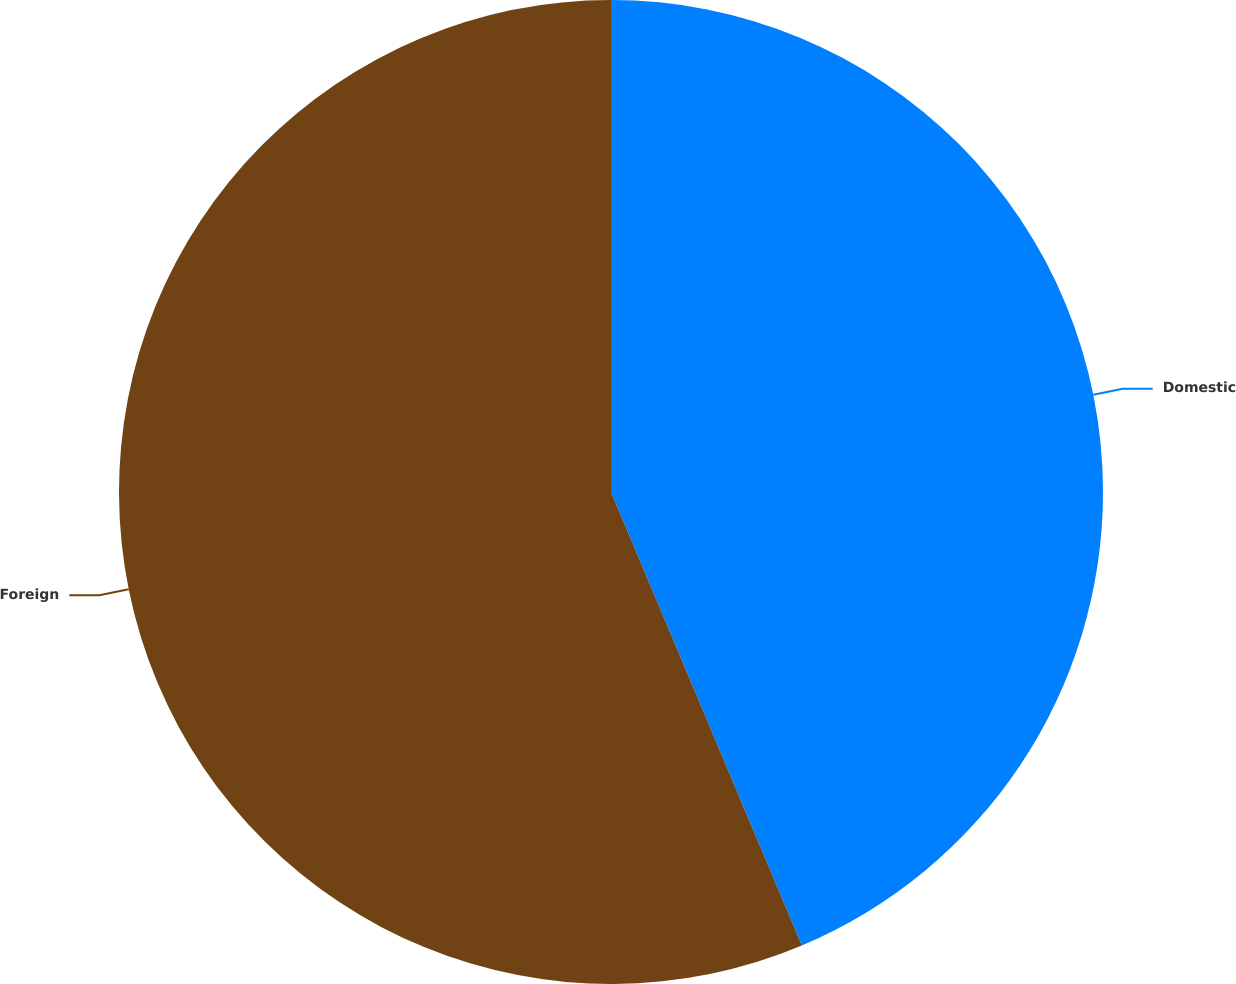<chart> <loc_0><loc_0><loc_500><loc_500><pie_chart><fcel>Domestic<fcel>Foreign<nl><fcel>43.66%<fcel>56.34%<nl></chart> 